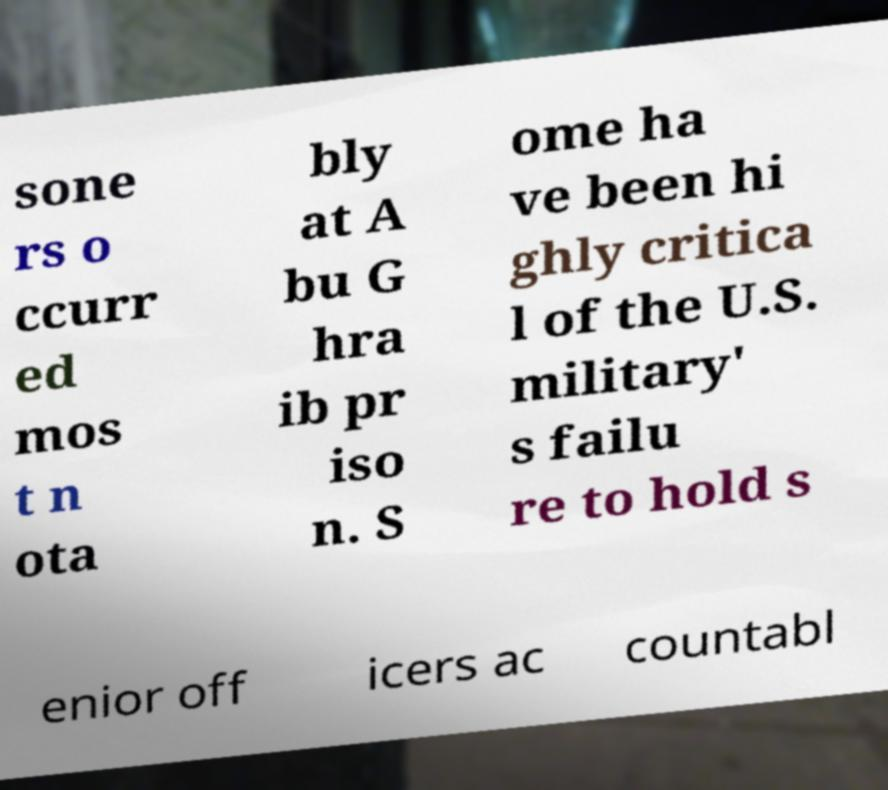Please read and relay the text visible in this image. What does it say? sone rs o ccurr ed mos t n ota bly at A bu G hra ib pr iso n. S ome ha ve been hi ghly critica l of the U.S. military' s failu re to hold s enior off icers ac countabl 